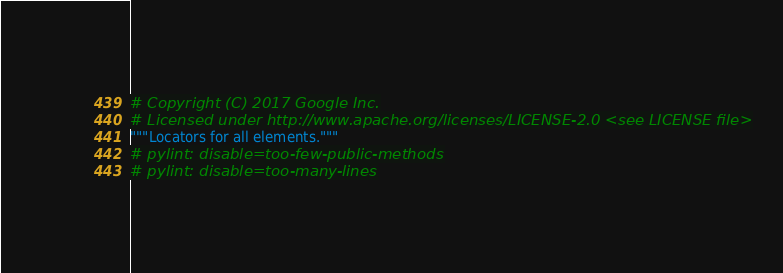<code> <loc_0><loc_0><loc_500><loc_500><_Python_># Copyright (C) 2017 Google Inc.
# Licensed under http://www.apache.org/licenses/LICENSE-2.0 <see LICENSE file>
"""Locators for all elements."""
# pylint: disable=too-few-public-methods
# pylint: disable=too-many-lines
</code> 